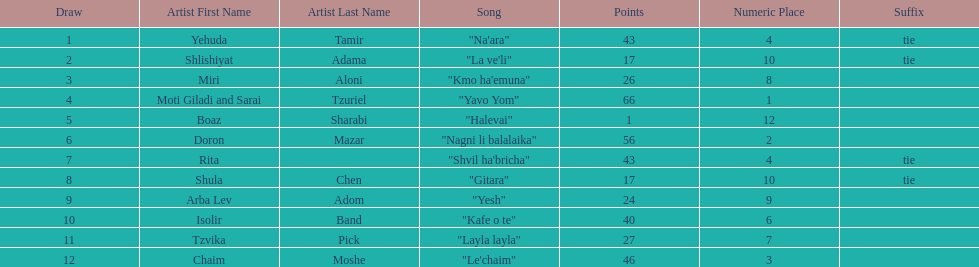What song is listed in the table right before layla layla? "Kafe o te". Would you mind parsing the complete table? {'header': ['Draw', 'Artist First Name', 'Artist Last Name', 'Song', 'Points', 'Numeric Place', 'Suffix'], 'rows': [['1', 'Yehuda', 'Tamir', '"Na\'ara"', '43', '4', 'tie'], ['2', 'Shlishiyat', 'Adama', '"La ve\'li"', '17', '10', 'tie'], ['3', 'Miri', 'Aloni', '"Kmo ha\'emuna"', '26', '8', ''], ['4', 'Moti Giladi and Sarai', 'Tzuriel', '"Yavo Yom"', '66', '1', ''], ['5', 'Boaz', 'Sharabi', '"Halevai"', '1', '12', ''], ['6', 'Doron', 'Mazar', '"Nagni li balalaika"', '56', '2', ''], ['7', 'Rita', '', '"Shvil ha\'bricha"', '43', '4', 'tie'], ['8', 'Shula', 'Chen', '"Gitara"', '17', '10', 'tie'], ['9', 'Arba Lev', 'Adom', '"Yesh"', '24', '9', ''], ['10', 'Isolir', 'Band', '"Kafe o te"', '40', '6', ''], ['11', 'Tzvika', 'Pick', '"Layla layla"', '27', '7', ''], ['12', 'Chaim', 'Moshe', '"Le\'chaim"', '46', '3', '']]} 